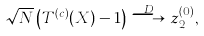Convert formula to latex. <formula><loc_0><loc_0><loc_500><loc_500>\sqrt { N } \left ( T ^ { ( c ) } ( { X } ) - 1 \right ) \stackrel { D } \longrightarrow z _ { 2 } ^ { ( 0 ) } ,</formula> 